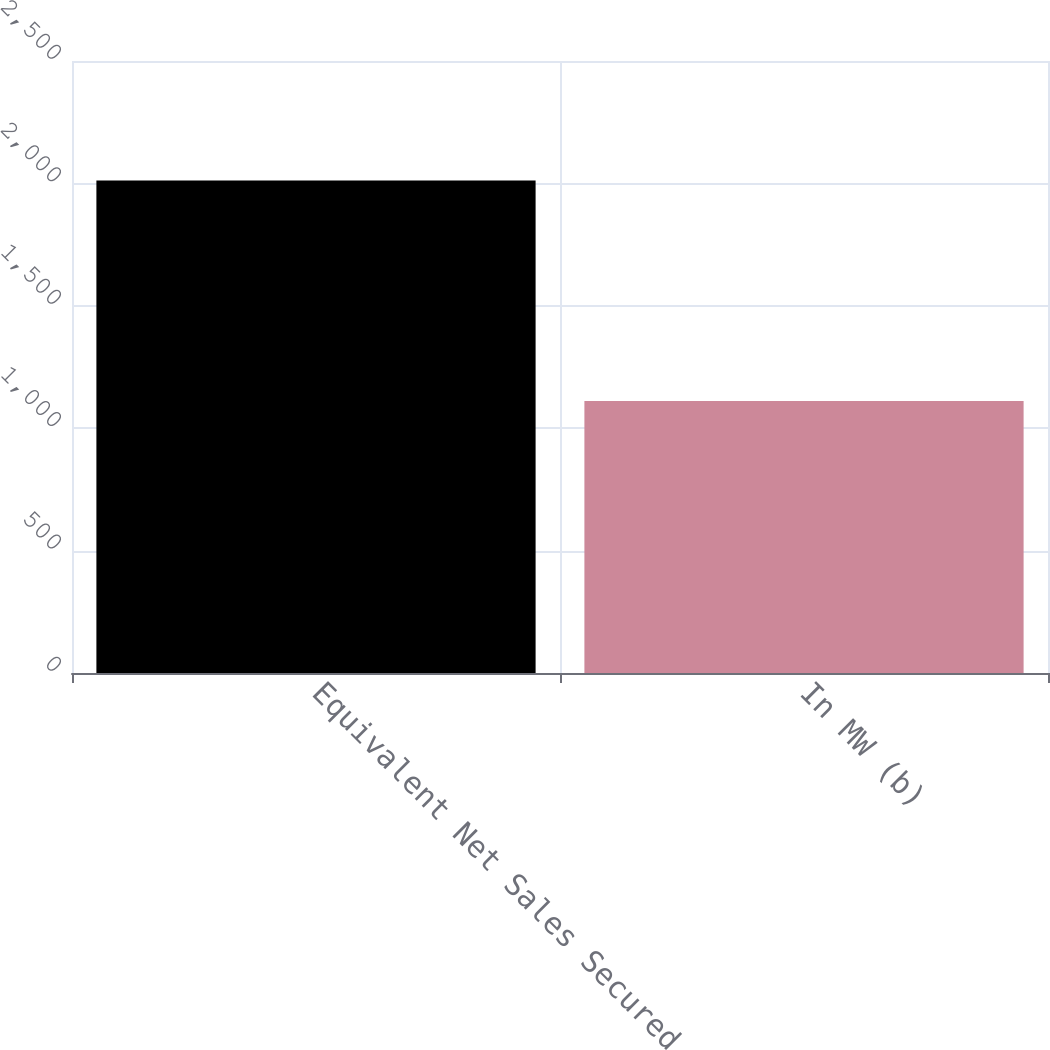Convert chart. <chart><loc_0><loc_0><loc_500><loc_500><bar_chart><fcel>Equivalent Net Sales Secured<fcel>In MW (b)<nl><fcel>2012<fcel>1111<nl></chart> 